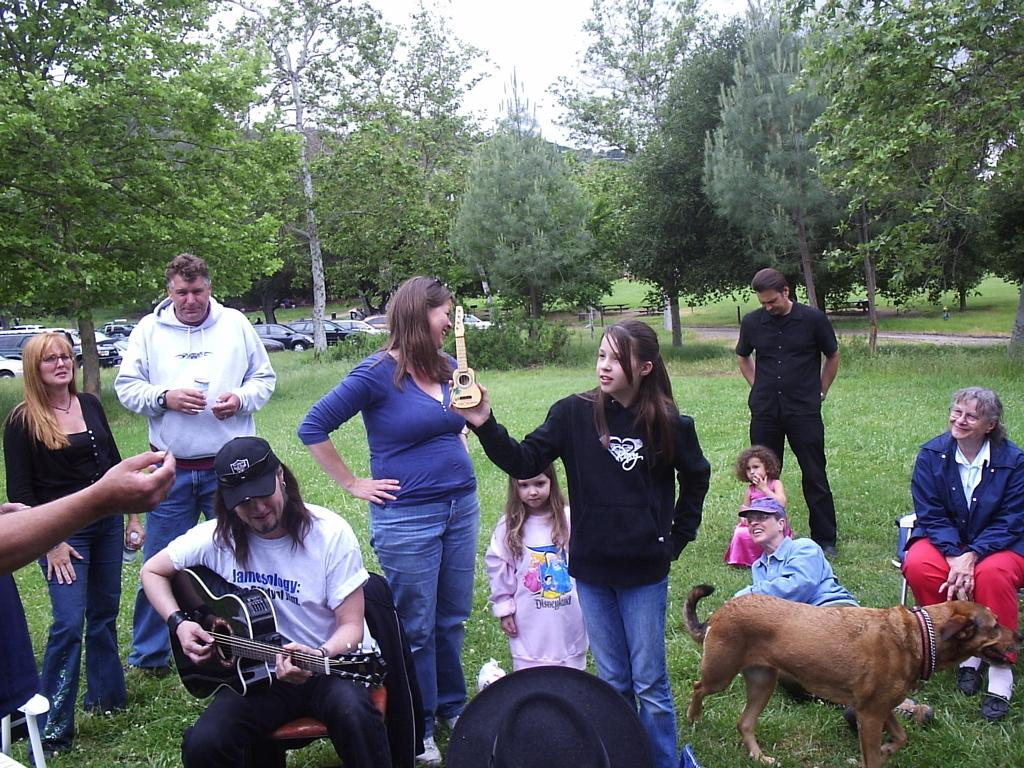What is the man in the image doing? The man is playing a guitar in the image. Are there any other people in the image besides the man playing the guitar? Yes, there are people around the man in the image. What other living creature can be seen in the image? There is a dog in the image. What can be seen in the background of the image? Trees, vehicles, and the sky are visible in the background of the image. What type of skirt is the gate wearing in the image? There is no gate or skirt present in the image. 